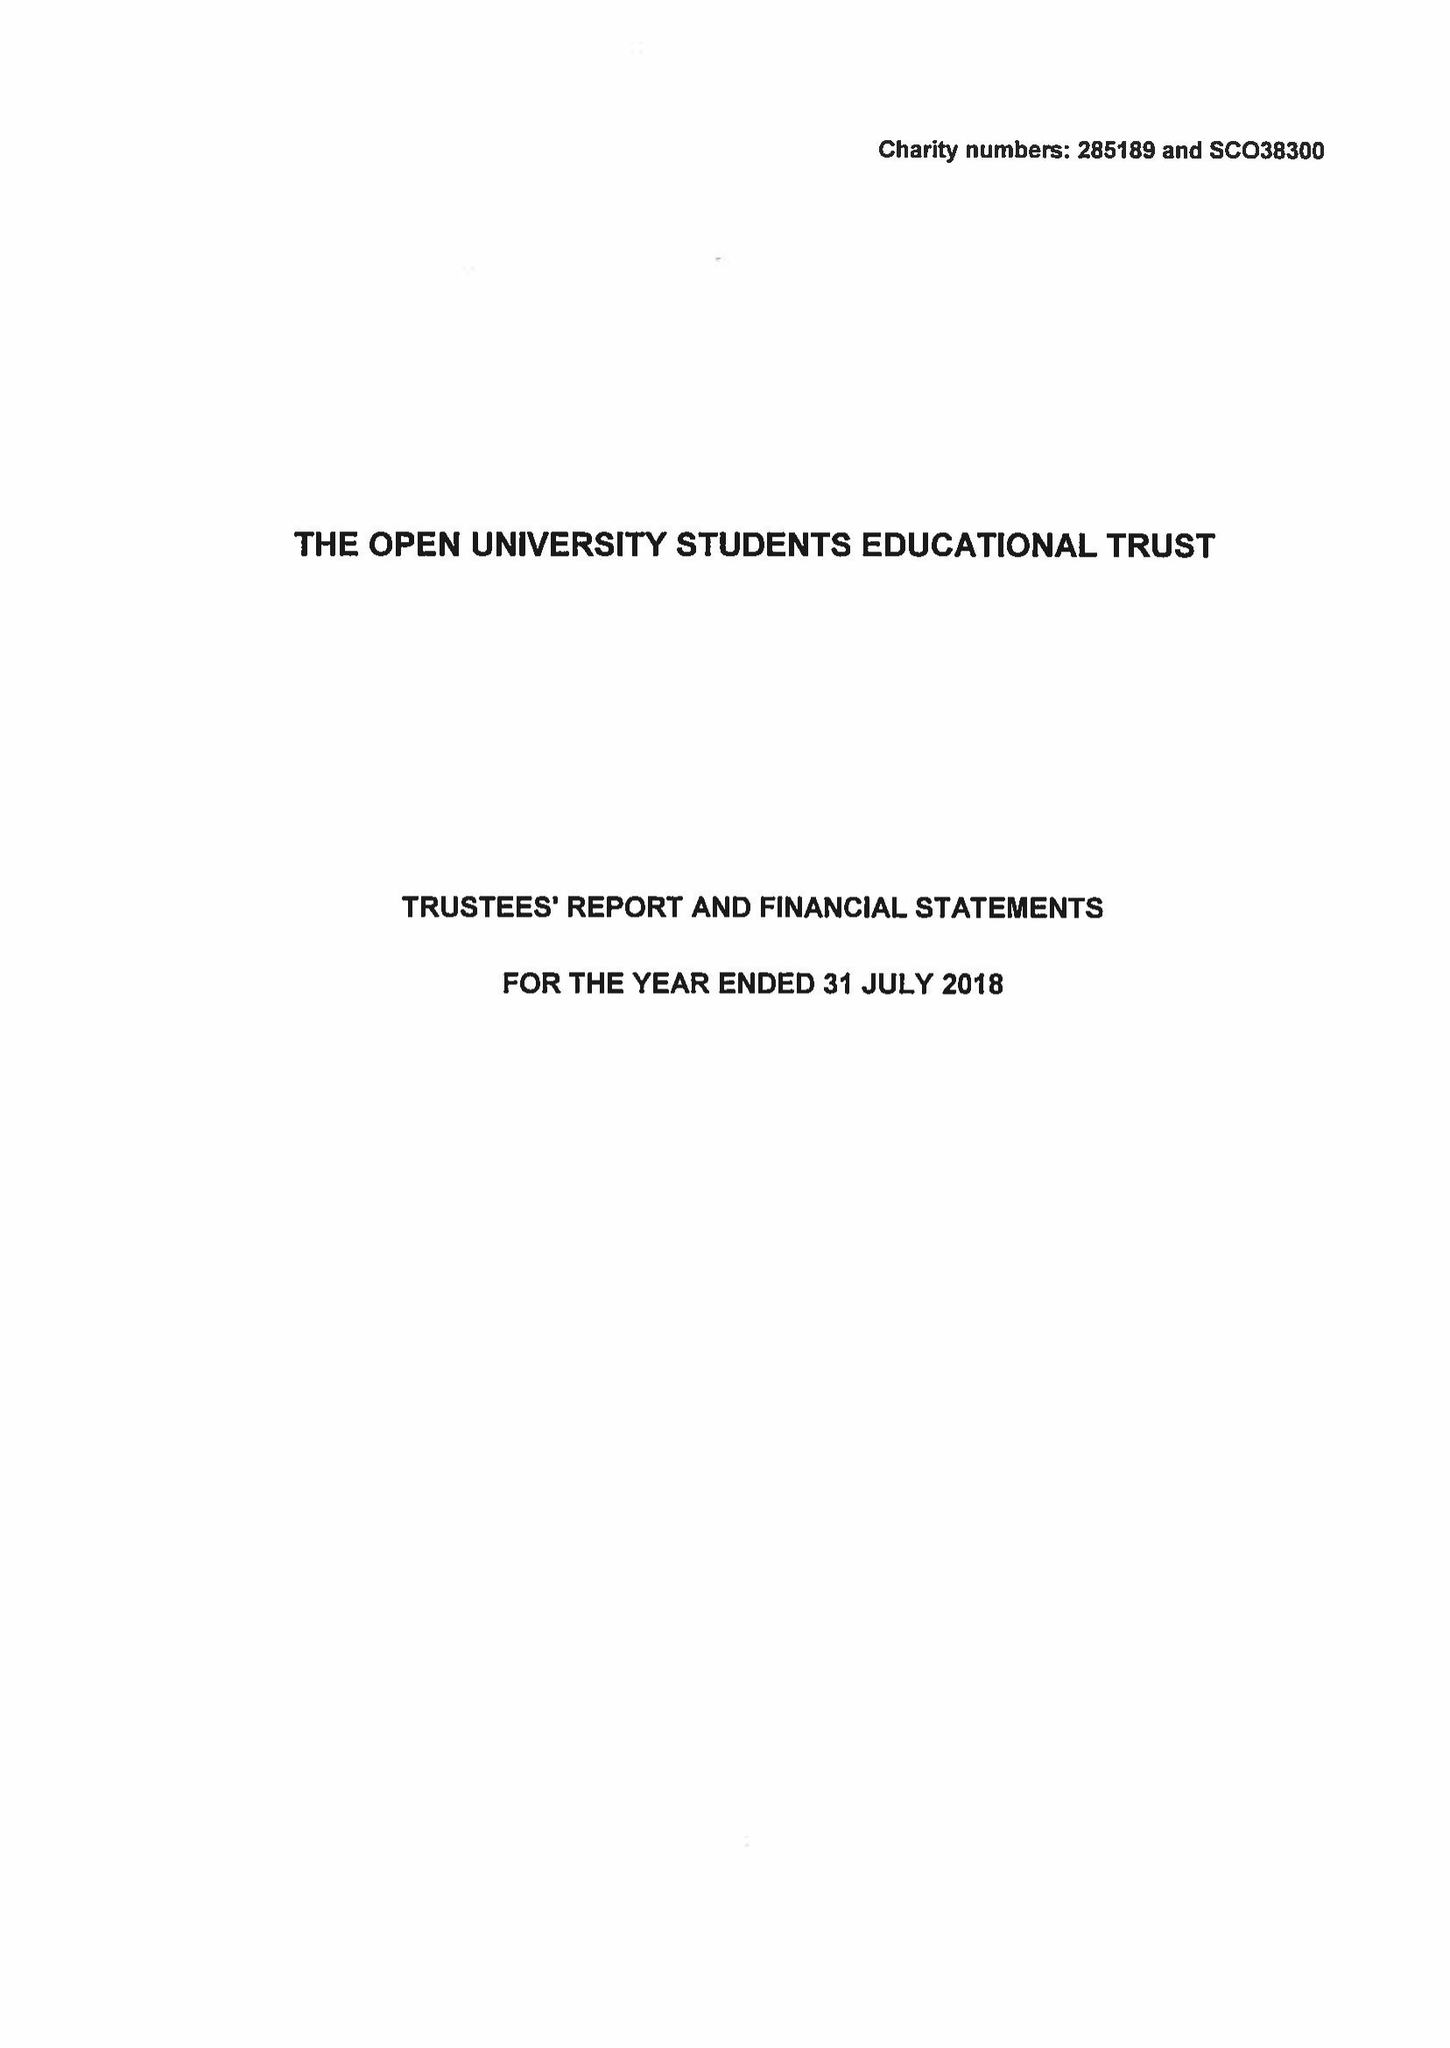What is the value for the report_date?
Answer the question using a single word or phrase. 2018-07-31 